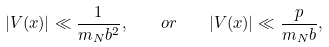<formula> <loc_0><loc_0><loc_500><loc_500>| V ( x ) | \ll \frac { 1 } { m _ { N } b ^ { 2 } } , \quad o r \quad | V ( x ) | \ll \frac { p } { m _ { N } b } ,</formula> 